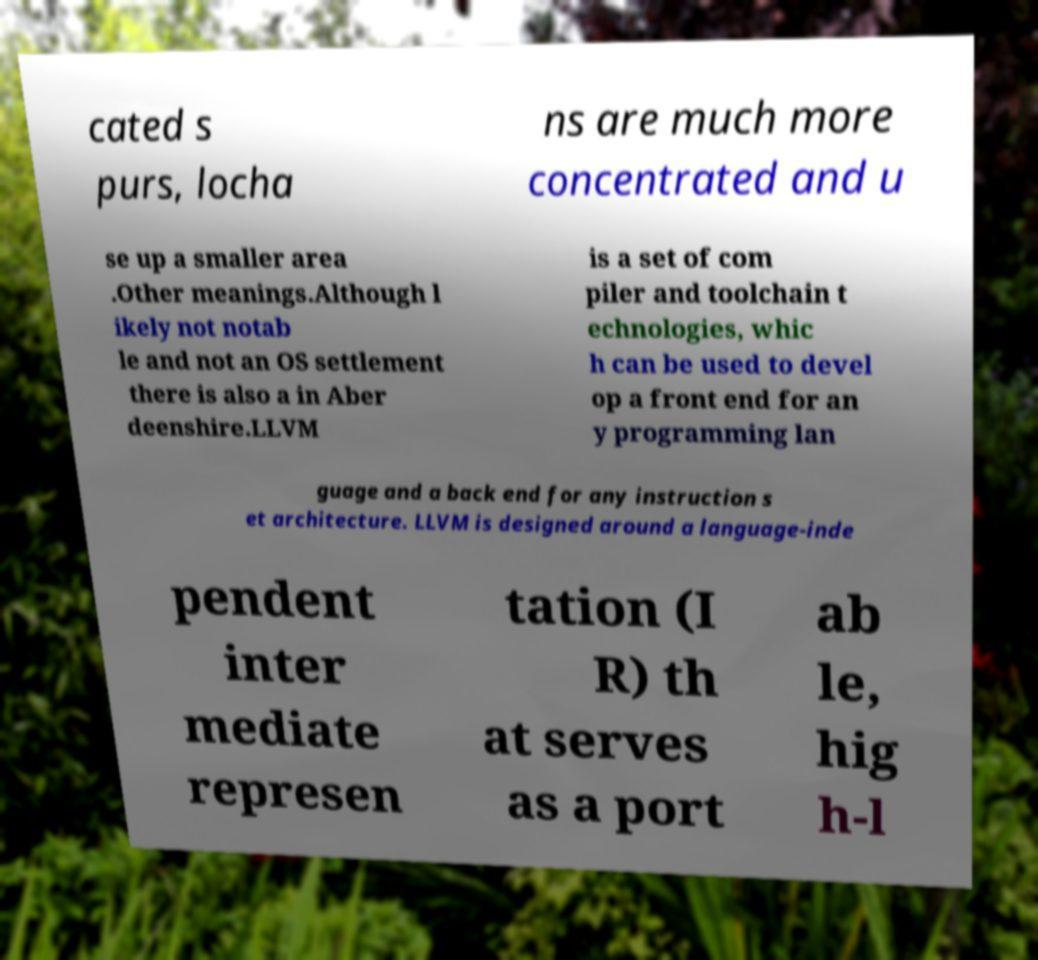What messages or text are displayed in this image? I need them in a readable, typed format. cated s purs, locha ns are much more concentrated and u se up a smaller area .Other meanings.Although l ikely not notab le and not an OS settlement there is also a in Aber deenshire.LLVM is a set of com piler and toolchain t echnologies, whic h can be used to devel op a front end for an y programming lan guage and a back end for any instruction s et architecture. LLVM is designed around a language-inde pendent inter mediate represen tation (I R) th at serves as a port ab le, hig h-l 